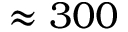Convert formula to latex. <formula><loc_0><loc_0><loc_500><loc_500>\approx 3 0 0</formula> 